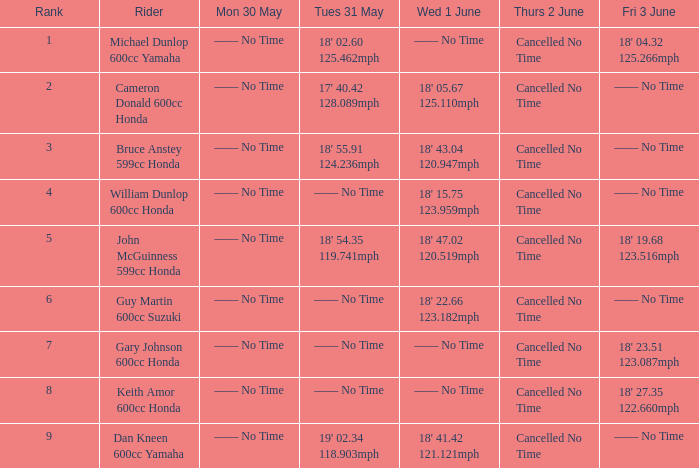What is the quantity of riders who achieved an 18' 5 1.0. 